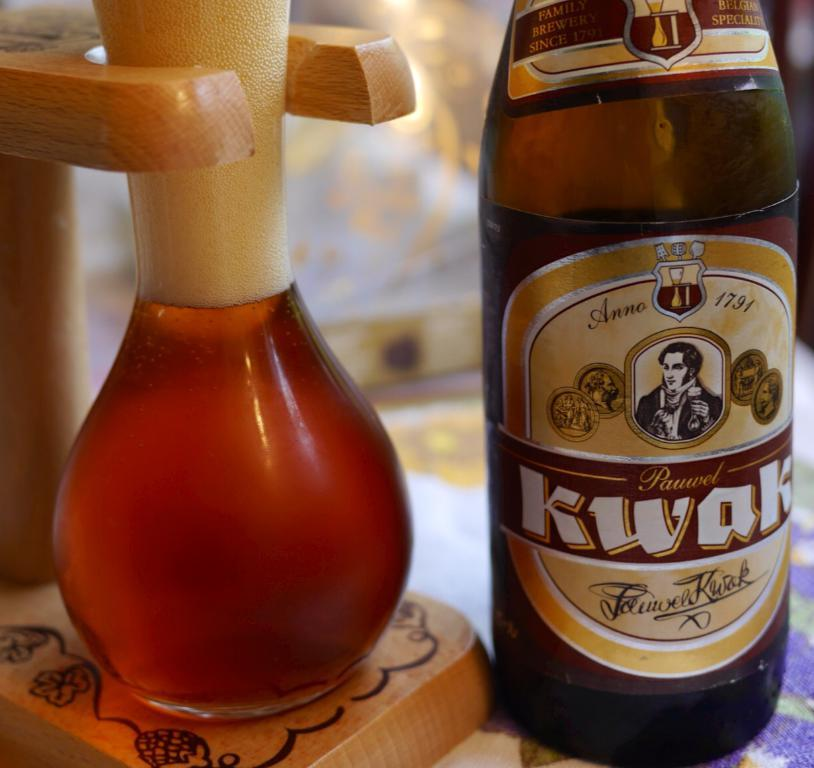<image>
Share a concise interpretation of the image provided. a bottle of anne 1731 pauwel kwak sitting next to a glass of it 